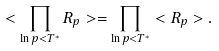<formula> <loc_0><loc_0><loc_500><loc_500>< \prod _ { \ln p < T ^ { * } } R _ { p } > = \prod _ { \ln p < T ^ { * } } < R _ { p } > .</formula> 